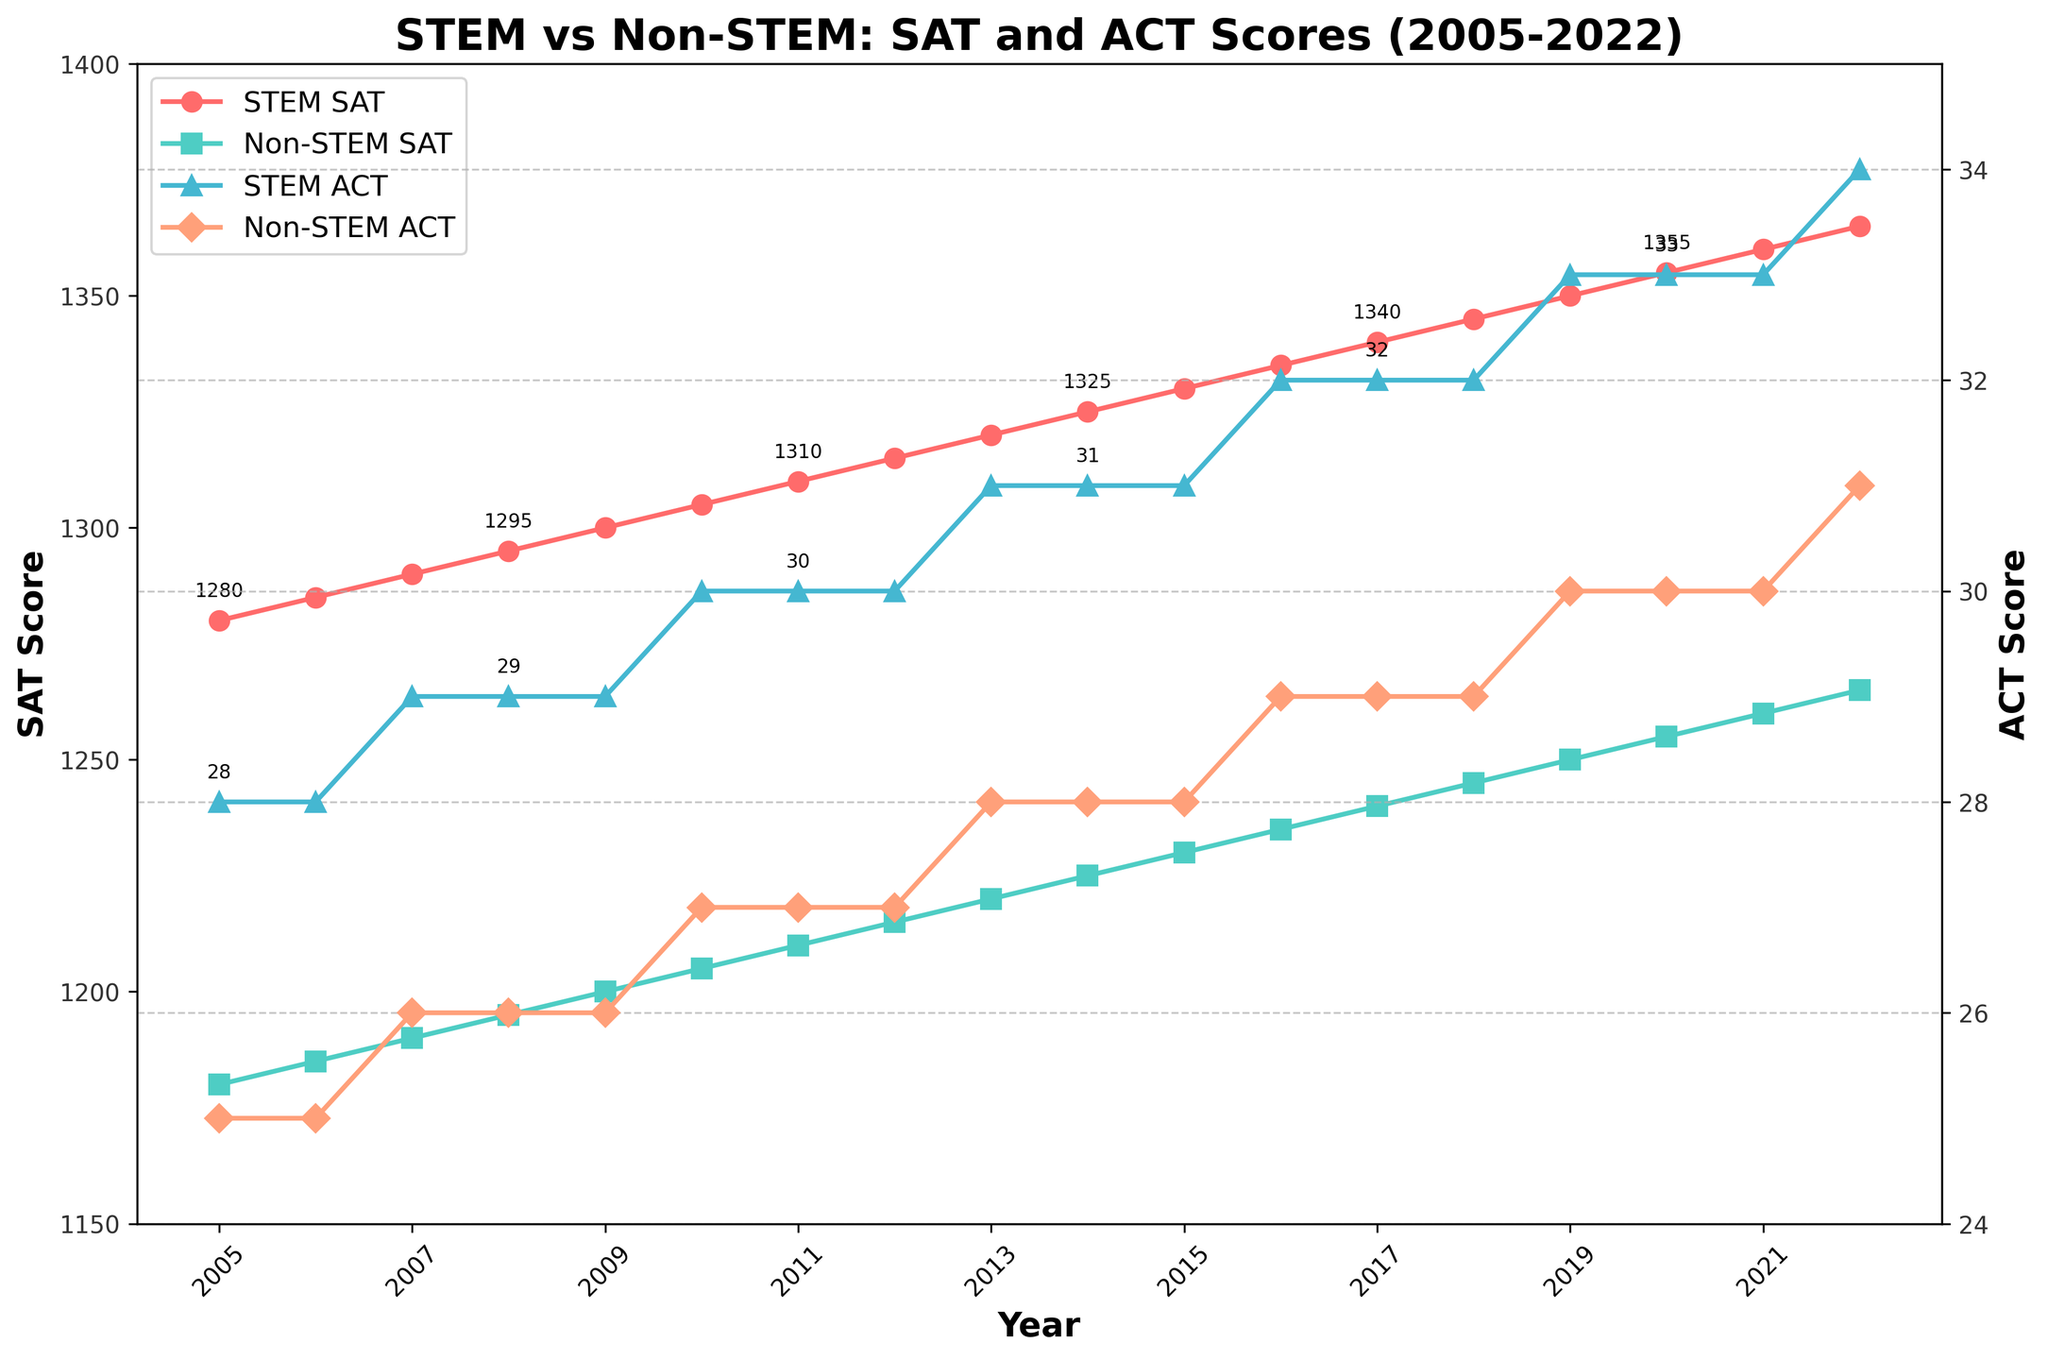What is the difference in SAT scores between STEM and Non-STEM students in 2022? To find the difference in SAT scores between STEM and Non-STEM students in 2022, subtract the Non-STEM SAT score from the STEM SAT score: 1365 (STEM) - 1265 (Non-STEM) = 100
Answer: 100 What trend can be observed in the ACT scores for STEM students from 2005 to 2022? The ACT scores for STEM students gradually increase over the years. Initially starting at 28 in 2005 and reaching 34 by 2022, the scores consistently rise with time.
Answer: Increasing trend Between which years did the SAT score for Non-STEM students show the largest increase? Examine the SAT scores for Non-STEM students year-by-year from the chart. The most significant increase is from 2016 (1235) to 2017 (1240), where the score increased by 5 points.
Answer: 2016 to 2017 Which year shows the smallest gap between STEM and Non-STEM SAT scores? To find the smallest gap, subtract Non-STEM SAT scores from STEM SAT scores for each year, then find the minimum difference. The smallest gap is in 2005: 1280 (STEM) - 1180 (Non-STEM) = 100.
Answer: 2005 What was the SAT score for STEM students in 2013 and how much did it increase by 2018? The SAT score for STEM students in 2013 is 1320. By 2018, it increased to 1345. The difference is 1345 - 1320 = 25.
Answer: 25 How does the SAT score for Non-STEM students in 2010 compare to the ACT score for STEM students in the same year? The SAT score for Non-STEM students in 2010 is 1205, while the ACT score for STEM students is 30. SAT scores and ACT scores are different metrics, so direct comparison in scale isn't straightforward.
Answer: Different metrics If the SAT score gap in 2015 was 100 points between STEM and Non-STEM students, what was the Non-STEM SAT score? The STEM SAT score in 2015 was 1330. The Non-STEM SAT score would be: 1330 - 100 = 1230.
Answer: 1230 Compare the highest and lowest ACT scores for STEM students over the entire period. The highest ACT score for STEM students over the entire period is 34 in 2022. The lowest ACT score for STEM students is 28 in 2005.
Answer: 34 and 28 